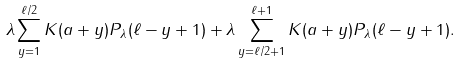Convert formula to latex. <formula><loc_0><loc_0><loc_500><loc_500>\lambda \sum _ { y = 1 } ^ { \ell / 2 } K ( a + y ) { P _ { \lambda } } ( \ell - y + 1 ) + \lambda \sum _ { y = \ell / 2 + 1 } ^ { \ell + 1 } K ( a + y ) { P _ { \lambda } } ( \ell - y + 1 ) .</formula> 